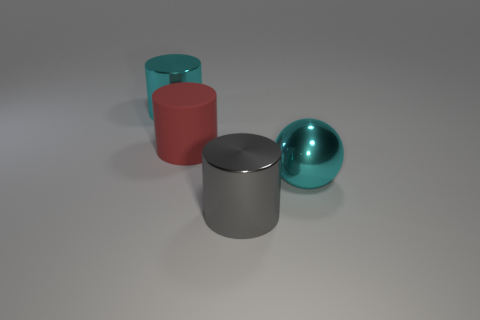Are there more things in front of the large cyan shiny cylinder than large shiny things behind the cyan ball?
Offer a very short reply. Yes. There is a big cylinder that is the same color as the large sphere; what is its material?
Your answer should be compact. Metal. Is there any other thing that is the same shape as the large red rubber object?
Your answer should be compact. Yes. There is a large cylinder that is both on the left side of the gray thing and in front of the cyan metallic cylinder; what is its material?
Keep it short and to the point. Rubber. Does the big gray cylinder have the same material as the cyan thing to the left of the cyan sphere?
Ensure brevity in your answer.  Yes. Are there any other things that are the same size as the cyan shiny cylinder?
Offer a very short reply. Yes. What number of objects are either red rubber objects or large gray cylinders that are in front of the matte cylinder?
Make the answer very short. 2. There is a shiny object behind the red cylinder; is it the same size as the cylinder in front of the large rubber thing?
Keep it short and to the point. Yes. How many other things are the same color as the matte cylinder?
Provide a succinct answer. 0. Does the cyan cylinder have the same size as the cyan metallic thing that is on the right side of the big gray shiny cylinder?
Give a very brief answer. Yes. 